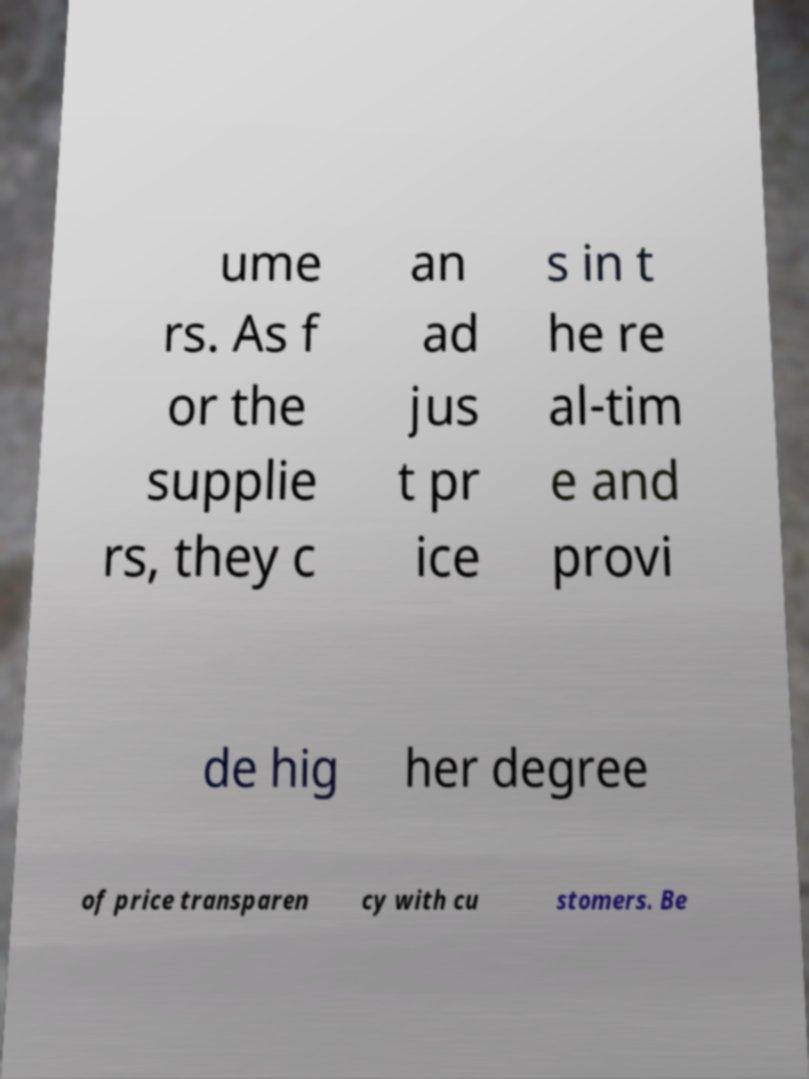I need the written content from this picture converted into text. Can you do that? ume rs. As f or the supplie rs, they c an ad jus t pr ice s in t he re al-tim e and provi de hig her degree of price transparen cy with cu stomers. Be 